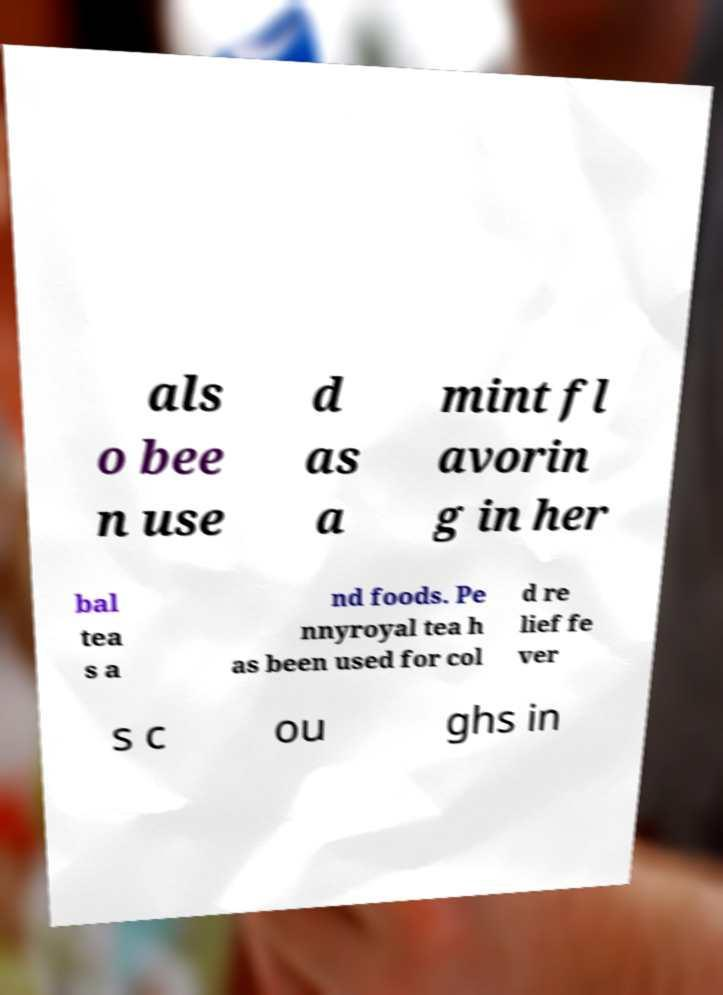What messages or text are displayed in this image? I need them in a readable, typed format. als o bee n use d as a mint fl avorin g in her bal tea s a nd foods. Pe nnyroyal tea h as been used for col d re lief fe ver s c ou ghs in 